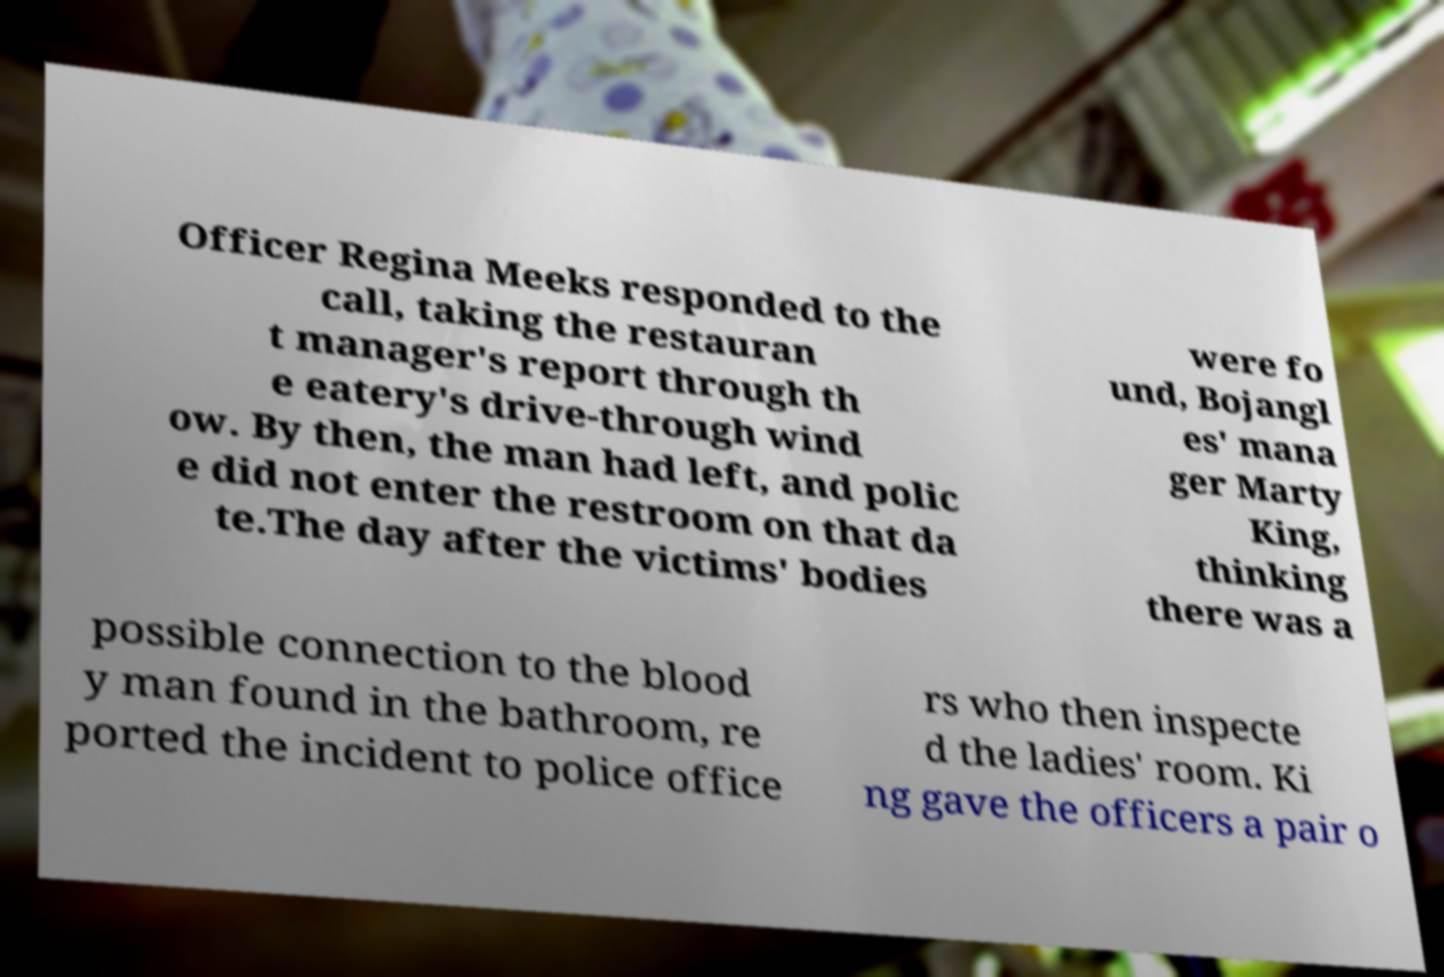Can you accurately transcribe the text from the provided image for me? Officer Regina Meeks responded to the call, taking the restauran t manager's report through th e eatery's drive-through wind ow. By then, the man had left, and polic e did not enter the restroom on that da te.The day after the victims' bodies were fo und, Bojangl es' mana ger Marty King, thinking there was a possible connection to the blood y man found in the bathroom, re ported the incident to police office rs who then inspecte d the ladies' room. Ki ng gave the officers a pair o 